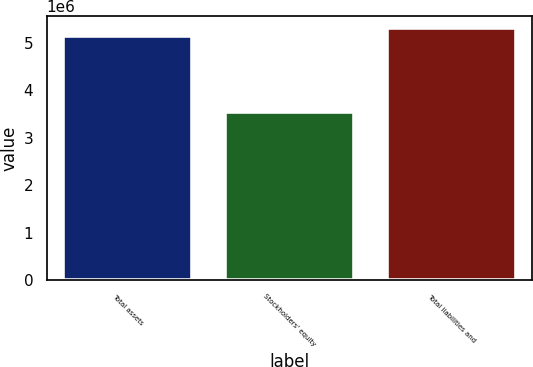Convert chart. <chart><loc_0><loc_0><loc_500><loc_500><bar_chart><fcel>Total assets<fcel>Stockholders' equity<fcel>Total liabilities and<nl><fcel>5.14745e+06<fcel>3.54175e+06<fcel>5.30802e+06<nl></chart> 